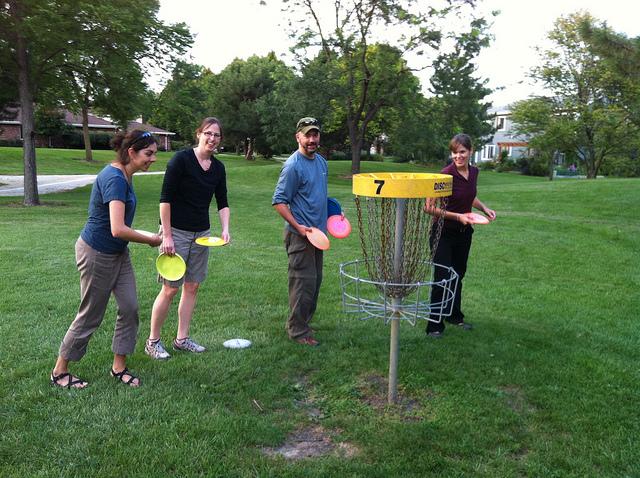Are the people happy?
Quick response, please. Yes. What are they holding?
Keep it brief. Frisbees. What color is the woman's headband?
Short answer required. Blue. What sport is being played?
Give a very brief answer. Frisbee. What color is the toy in the lady's hand?
Short answer required. Pink. What is the 7 for on the frisbee goal?
Answer briefly. Hole number. What number is at the top on the yellow?
Answer briefly. 7. What sport are they playing?
Answer briefly. Frisbee. What primary color is the man wearing?
Be succinct. Blue. 